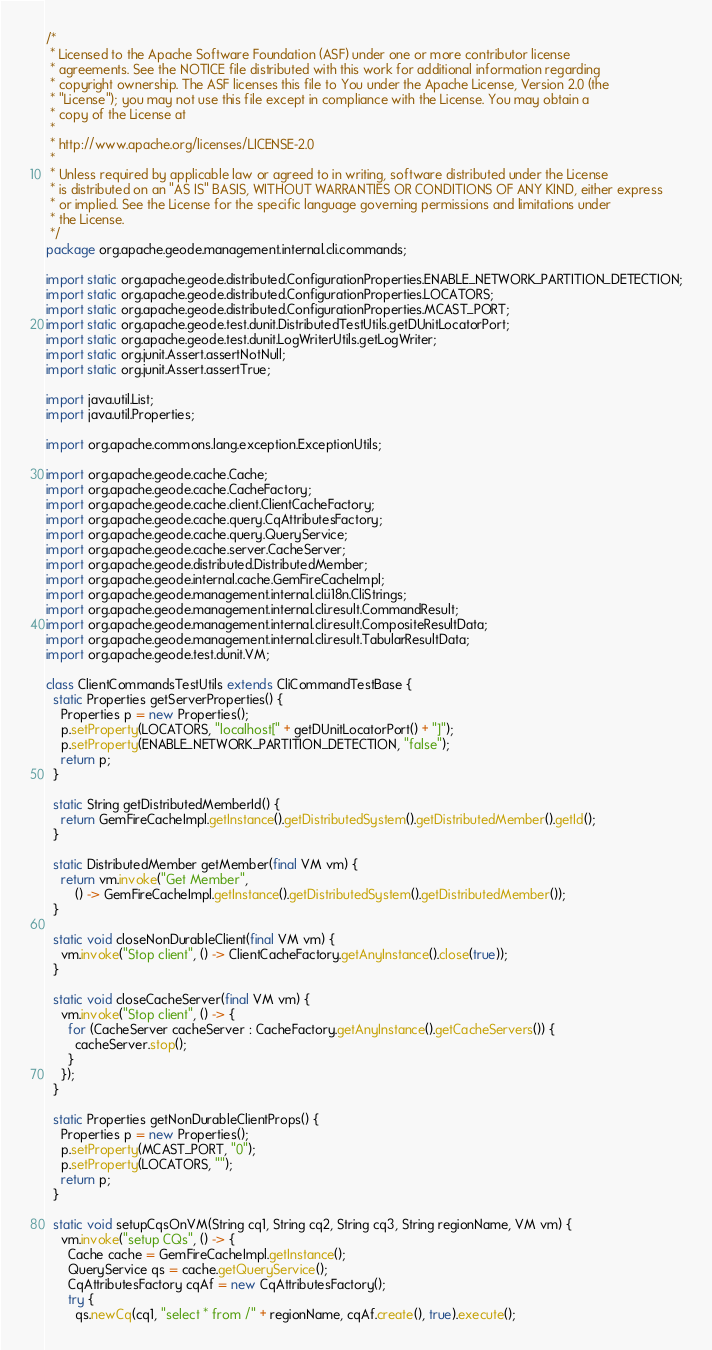<code> <loc_0><loc_0><loc_500><loc_500><_Java_>/*
 * Licensed to the Apache Software Foundation (ASF) under one or more contributor license
 * agreements. See the NOTICE file distributed with this work for additional information regarding
 * copyright ownership. The ASF licenses this file to You under the Apache License, Version 2.0 (the
 * "License"); you may not use this file except in compliance with the License. You may obtain a
 * copy of the License at
 *
 * http://www.apache.org/licenses/LICENSE-2.0
 *
 * Unless required by applicable law or agreed to in writing, software distributed under the License
 * is distributed on an "AS IS" BASIS, WITHOUT WARRANTIES OR CONDITIONS OF ANY KIND, either express
 * or implied. See the License for the specific language governing permissions and limitations under
 * the License.
 */
package org.apache.geode.management.internal.cli.commands;

import static org.apache.geode.distributed.ConfigurationProperties.ENABLE_NETWORK_PARTITION_DETECTION;
import static org.apache.geode.distributed.ConfigurationProperties.LOCATORS;
import static org.apache.geode.distributed.ConfigurationProperties.MCAST_PORT;
import static org.apache.geode.test.dunit.DistributedTestUtils.getDUnitLocatorPort;
import static org.apache.geode.test.dunit.LogWriterUtils.getLogWriter;
import static org.junit.Assert.assertNotNull;
import static org.junit.Assert.assertTrue;

import java.util.List;
import java.util.Properties;

import org.apache.commons.lang.exception.ExceptionUtils;

import org.apache.geode.cache.Cache;
import org.apache.geode.cache.CacheFactory;
import org.apache.geode.cache.client.ClientCacheFactory;
import org.apache.geode.cache.query.CqAttributesFactory;
import org.apache.geode.cache.query.QueryService;
import org.apache.geode.cache.server.CacheServer;
import org.apache.geode.distributed.DistributedMember;
import org.apache.geode.internal.cache.GemFireCacheImpl;
import org.apache.geode.management.internal.cli.i18n.CliStrings;
import org.apache.geode.management.internal.cli.result.CommandResult;
import org.apache.geode.management.internal.cli.result.CompositeResultData;
import org.apache.geode.management.internal.cli.result.TabularResultData;
import org.apache.geode.test.dunit.VM;

class ClientCommandsTestUtils extends CliCommandTestBase {
  static Properties getServerProperties() {
    Properties p = new Properties();
    p.setProperty(LOCATORS, "localhost[" + getDUnitLocatorPort() + "]");
    p.setProperty(ENABLE_NETWORK_PARTITION_DETECTION, "false");
    return p;
  }

  static String getDistributedMemberId() {
    return GemFireCacheImpl.getInstance().getDistributedSystem().getDistributedMember().getId();
  }

  static DistributedMember getMember(final VM vm) {
    return vm.invoke("Get Member",
        () -> GemFireCacheImpl.getInstance().getDistributedSystem().getDistributedMember());
  }

  static void closeNonDurableClient(final VM vm) {
    vm.invoke("Stop client", () -> ClientCacheFactory.getAnyInstance().close(true));
  }

  static void closeCacheServer(final VM vm) {
    vm.invoke("Stop client", () -> {
      for (CacheServer cacheServer : CacheFactory.getAnyInstance().getCacheServers()) {
        cacheServer.stop();
      }
    });
  }

  static Properties getNonDurableClientProps() {
    Properties p = new Properties();
    p.setProperty(MCAST_PORT, "0");
    p.setProperty(LOCATORS, "");
    return p;
  }

  static void setupCqsOnVM(String cq1, String cq2, String cq3, String regionName, VM vm) {
    vm.invoke("setup CQs", () -> {
      Cache cache = GemFireCacheImpl.getInstance();
      QueryService qs = cache.getQueryService();
      CqAttributesFactory cqAf = new CqAttributesFactory();
      try {
        qs.newCq(cq1, "select * from /" + regionName, cqAf.create(), true).execute();</code> 